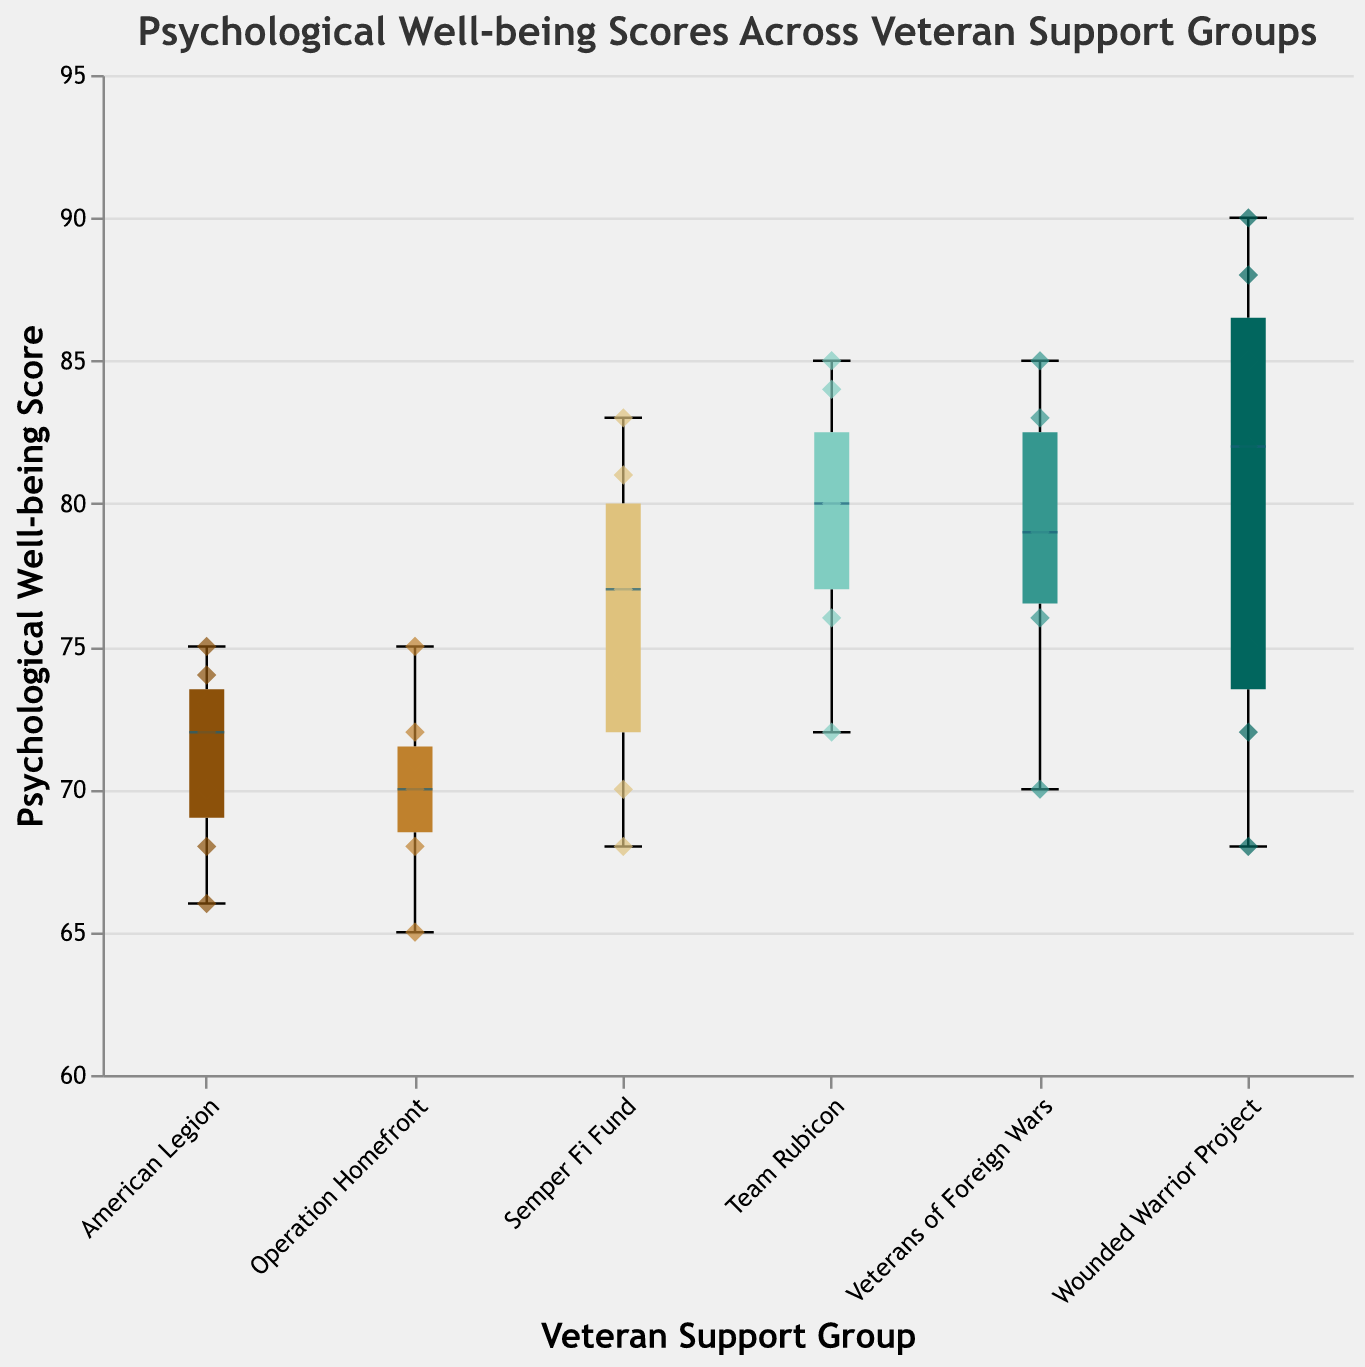What is the title of the figure? The title of the figure is displayed at the top and reads, "Psychological Well-being Scores Across Veteran Support Groups."
Answer: Psychological Well-being Scores Across Veteran Support Groups Which veteran support group has the highest individual well-being score? By examining the scatter points, the highest well-being score is 90, which belongs to Wounded Warrior Project.
Answer: Wounded Warrior Project What is the median psychological well-being score for Team Rubicon? The median is denoted by the line inside the box plot for Team Rubicon. It is at 80 based on the figure.
Answer: 80 Which group has the lowest median well-being score? The median lines within the box plots show that Operation Homefront has the lowest median score.
Answer: Operation Homefront Which two groups have the most overlapping interquartile ranges (IQRs)? Observing the boxes (which represent IQRs), Team Rubicon and Semper Fi Fund have notably overlapping IQRs.
Answer: Team Rubicon and Semper Fi Fund What is the range of psychological well-being scores for American Legion? The range is determined by the minimum and maximum values shown by the whiskers. For American Legion, it ranges from 66 to 75.
Answer: 66 to 75 How does the median score of Veterans of Foreign Wars compare to that of Wounded Warrior Project? The median line of Veterans of Foreign Wars is 79, whereas Wounded Warrior Project's median is 82. Comparing these shows that Wounded Warrior Project has a higher median score.
Answer: Wounded Warrior Project has a higher median score What group shows the highest variability in psychological well-being scores? The group with the highest variability will have the longest whiskers. Wounded Warrior Project shows the highest variability with scores ranging from 68 to 90.
Answer: Wounded Warrior Project What are the upper and lower quartiles for Semper Fi Fund? The upper quartile (top edge of the box) is around 81, and the lower quartile (bottom edge of the box) is about 70 for Semper Fi Fund.
Answer: Upper: 81, Lower: 70 How many veteran support groups have data points above 85? Observing the scatter points, Wounded Warrior Project has data points above 85, specifically at 88 and 90. Veterans of Foreign Wars also has a point at 85.
Answer: Two groups (Wounded Warrior Project and Veterans of Foreign Wars) 